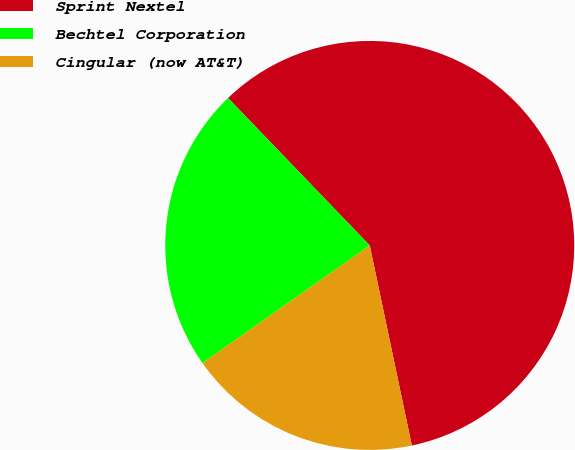Convert chart to OTSL. <chart><loc_0><loc_0><loc_500><loc_500><pie_chart><fcel>Sprint Nextel<fcel>Bechtel Corporation<fcel>Cingular (now AT&T)<nl><fcel>58.88%<fcel>22.57%<fcel>18.54%<nl></chart> 